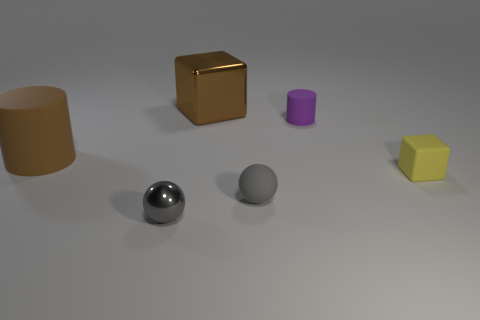What number of other things are there of the same material as the yellow object
Offer a terse response. 3. What is the yellow object made of?
Your response must be concise. Rubber. What size is the rubber thing right of the small purple cylinder?
Provide a succinct answer. Small. There is a small matte thing that is in front of the rubber block; how many shiny things are behind it?
Your answer should be compact. 1. There is a big thing that is behind the small purple object; is its shape the same as the tiny gray thing left of the small rubber ball?
Ensure brevity in your answer.  No. How many matte things are both to the left of the small yellow matte block and on the right side of the large brown matte cylinder?
Offer a very short reply. 2. Is there a matte cylinder of the same color as the shiny block?
Provide a succinct answer. Yes. What shape is the metallic thing that is the same size as the brown cylinder?
Offer a terse response. Cube. There is a matte sphere; are there any objects behind it?
Your answer should be compact. Yes. Are the small object that is behind the tiny matte block and the small gray thing that is behind the small shiny object made of the same material?
Provide a succinct answer. Yes. 